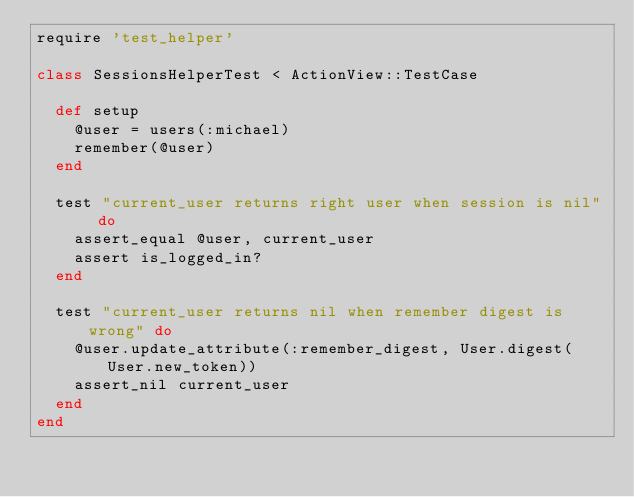Convert code to text. <code><loc_0><loc_0><loc_500><loc_500><_Ruby_>require 'test_helper' 

class SessionsHelperTest < ActionView::TestCase

  def setup
    @user = users(:michael)
    remember(@user)
  end

  test "current_user returns right user when session is nil" do
    assert_equal @user, current_user
    assert is_logged_in?  
  end

  test "current_user returns nil when remember digest is wrong" do
    @user.update_attribute(:remember_digest, User.digest(User.new_token)) 
    assert_nil current_user
  end
end</code> 